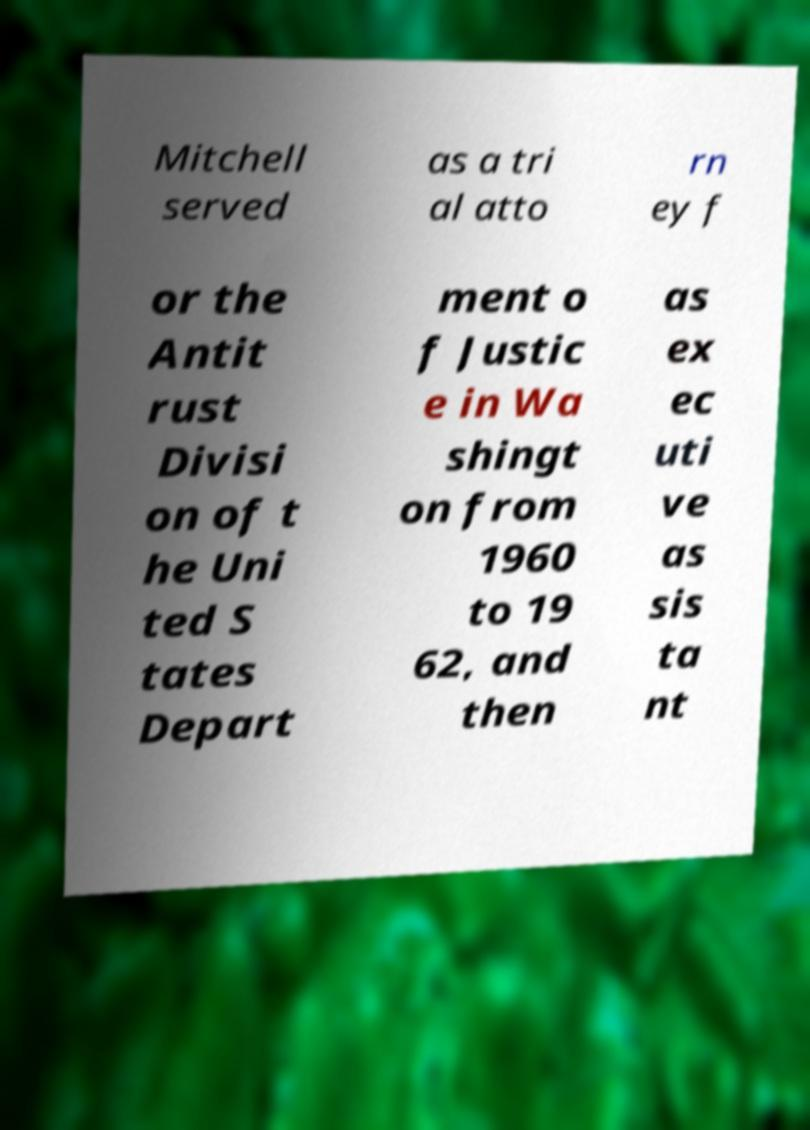For documentation purposes, I need the text within this image transcribed. Could you provide that? Mitchell served as a tri al atto rn ey f or the Antit rust Divisi on of t he Uni ted S tates Depart ment o f Justic e in Wa shingt on from 1960 to 19 62, and then as ex ec uti ve as sis ta nt 